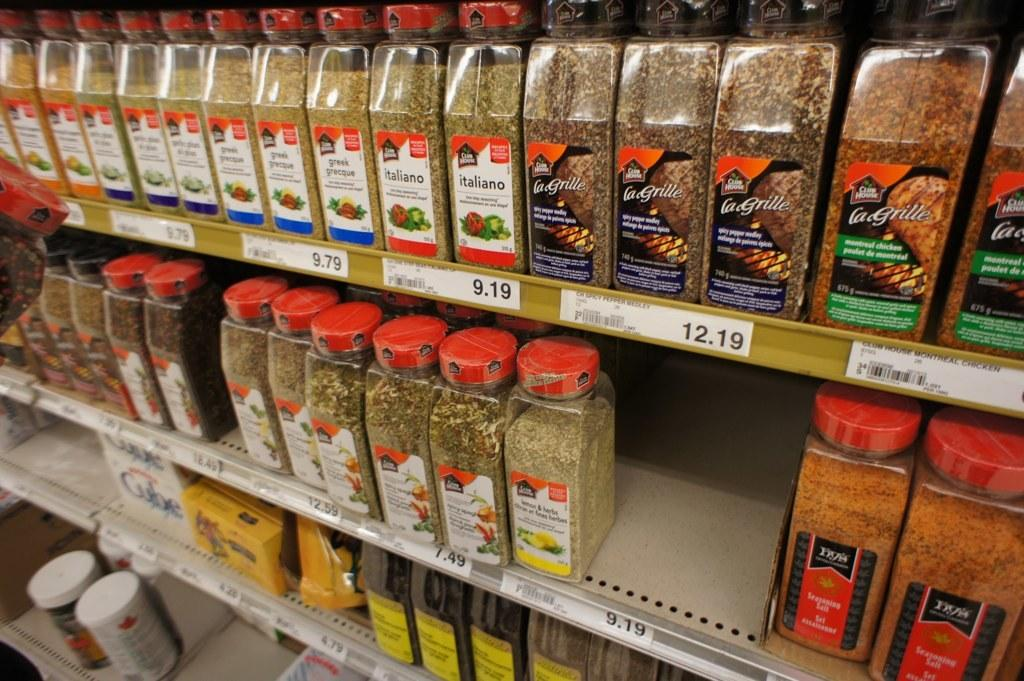<image>
Present a compact description of the photo's key features. The shelf in this store has mny lagrille containers. 